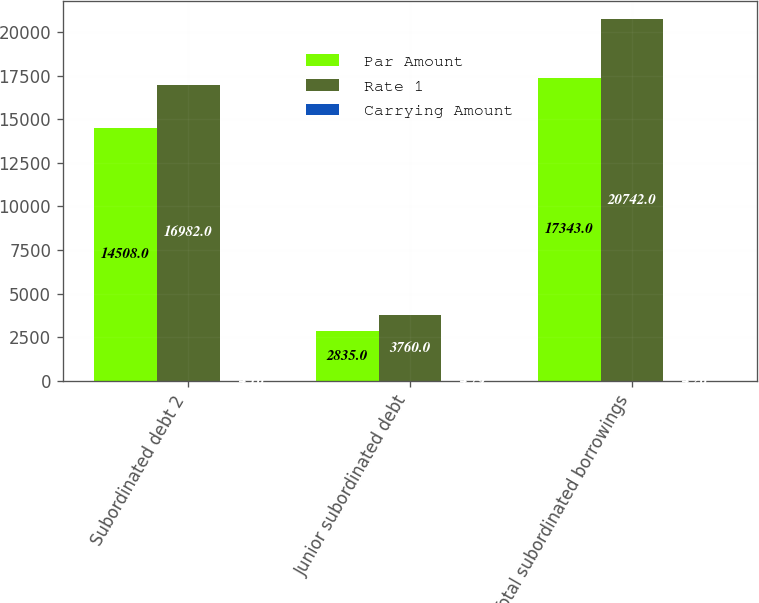<chart> <loc_0><loc_0><loc_500><loc_500><stacked_bar_chart><ecel><fcel>Subordinated debt 2<fcel>Junior subordinated debt<fcel>Total subordinated borrowings<nl><fcel>Par Amount<fcel>14508<fcel>2835<fcel>17343<nl><fcel>Rate 1<fcel>16982<fcel>3760<fcel>20742<nl><fcel>Carrying Amount<fcel>4.16<fcel>4.79<fcel>4.26<nl></chart> 